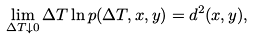Convert formula to latex. <formula><loc_0><loc_0><loc_500><loc_500>\lim _ { \Delta T \downarrow 0 } \Delta T \ln p ( \Delta T , x , y ) = d ^ { 2 } ( x , y ) ,</formula> 